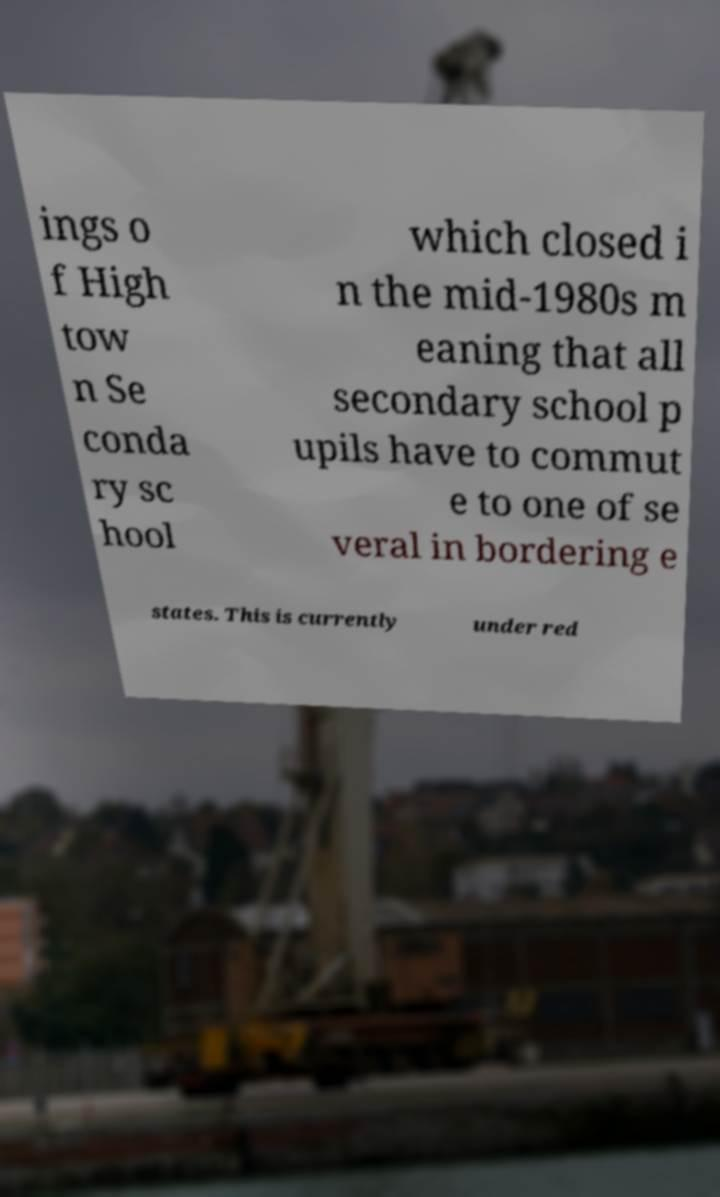For documentation purposes, I need the text within this image transcribed. Could you provide that? ings o f High tow n Se conda ry sc hool which closed i n the mid-1980s m eaning that all secondary school p upils have to commut e to one of se veral in bordering e states. This is currently under red 